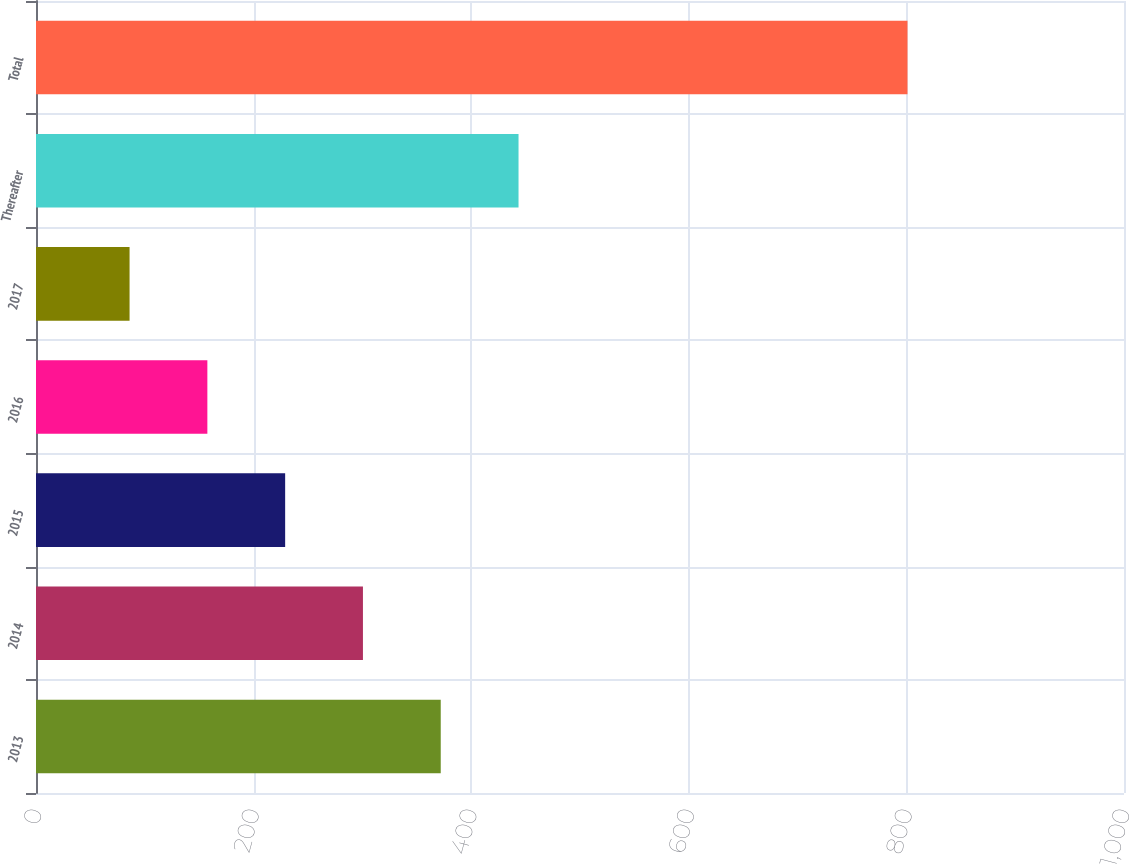<chart> <loc_0><loc_0><loc_500><loc_500><bar_chart><fcel>2013<fcel>2014<fcel>2015<fcel>2016<fcel>2017<fcel>Thereafter<fcel>Total<nl><fcel>372<fcel>300.5<fcel>229<fcel>157.5<fcel>86<fcel>443.5<fcel>801<nl></chart> 